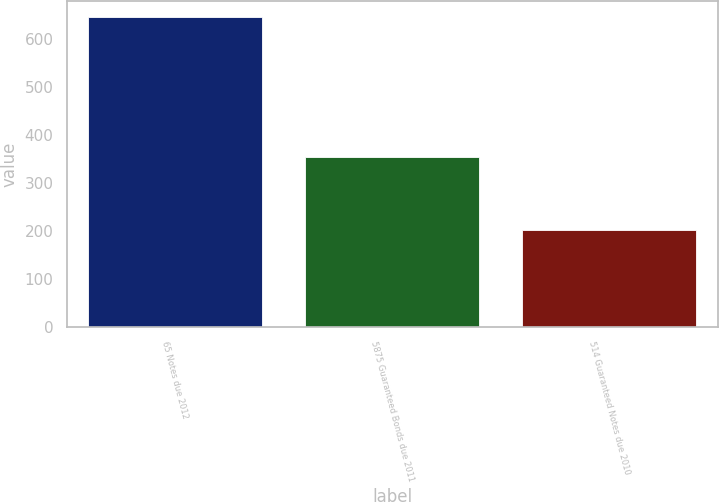<chart> <loc_0><loc_0><loc_500><loc_500><bar_chart><fcel>65 Notes due 2012<fcel>5875 Guaranteed Bonds due 2011<fcel>514 Guaranteed Notes due 2010<nl><fcel>647<fcel>355<fcel>203<nl></chart> 